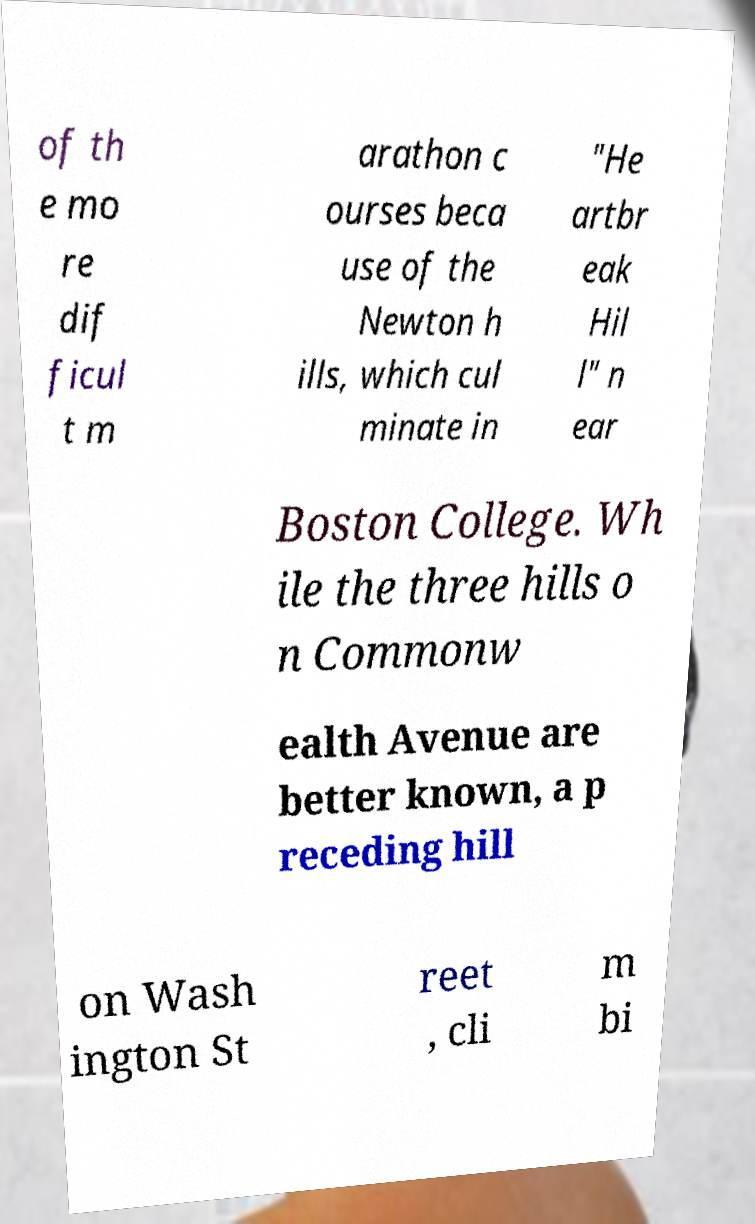What messages or text are displayed in this image? I need them in a readable, typed format. of th e mo re dif ficul t m arathon c ourses beca use of the Newton h ills, which cul minate in "He artbr eak Hil l" n ear Boston College. Wh ile the three hills o n Commonw ealth Avenue are better known, a p receding hill on Wash ington St reet , cli m bi 